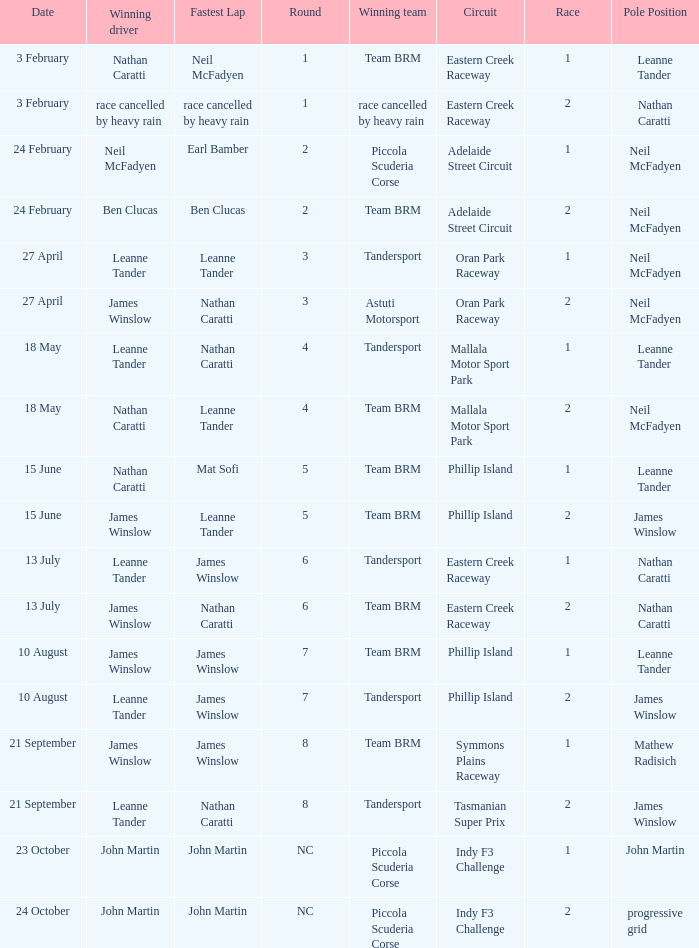Which race number in the Indy F3 Challenge circuit had John Martin in pole position? 1.0. 